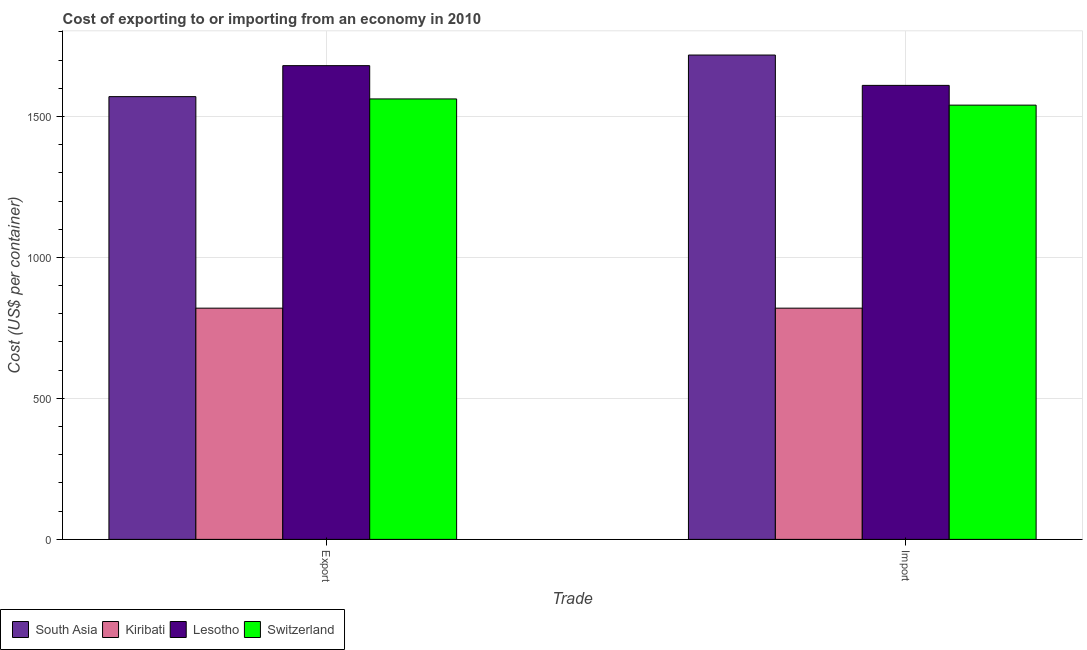How many groups of bars are there?
Keep it short and to the point. 2. Are the number of bars per tick equal to the number of legend labels?
Offer a very short reply. Yes. How many bars are there on the 1st tick from the right?
Ensure brevity in your answer.  4. What is the label of the 1st group of bars from the left?
Your answer should be very brief. Export. What is the import cost in Lesotho?
Your answer should be compact. 1610. Across all countries, what is the maximum import cost?
Your answer should be very brief. 1717.62. Across all countries, what is the minimum import cost?
Offer a very short reply. 820. In which country was the import cost maximum?
Keep it short and to the point. South Asia. In which country was the import cost minimum?
Make the answer very short. Kiribati. What is the total export cost in the graph?
Your answer should be very brief. 5632.12. What is the difference between the export cost in South Asia and that in Kiribati?
Provide a short and direct response. 750.12. What is the difference between the export cost in Lesotho and the import cost in Switzerland?
Provide a short and direct response. 140. What is the average import cost per country?
Ensure brevity in your answer.  1421.91. In how many countries, is the import cost greater than 900 US$?
Provide a succinct answer. 3. What is the ratio of the import cost in Lesotho to that in South Asia?
Offer a very short reply. 0.94. What does the 1st bar from the left in Import represents?
Offer a very short reply. South Asia. What does the 3rd bar from the right in Export represents?
Offer a terse response. Kiribati. What is the difference between two consecutive major ticks on the Y-axis?
Your response must be concise. 500. Are the values on the major ticks of Y-axis written in scientific E-notation?
Ensure brevity in your answer.  No. Where does the legend appear in the graph?
Your answer should be compact. Bottom left. How are the legend labels stacked?
Your answer should be very brief. Horizontal. What is the title of the graph?
Provide a succinct answer. Cost of exporting to or importing from an economy in 2010. What is the label or title of the X-axis?
Give a very brief answer. Trade. What is the label or title of the Y-axis?
Keep it short and to the point. Cost (US$ per container). What is the Cost (US$ per container) of South Asia in Export?
Ensure brevity in your answer.  1570.12. What is the Cost (US$ per container) in Kiribati in Export?
Keep it short and to the point. 820. What is the Cost (US$ per container) of Lesotho in Export?
Give a very brief answer. 1680. What is the Cost (US$ per container) of Switzerland in Export?
Ensure brevity in your answer.  1562. What is the Cost (US$ per container) of South Asia in Import?
Offer a very short reply. 1717.62. What is the Cost (US$ per container) in Kiribati in Import?
Ensure brevity in your answer.  820. What is the Cost (US$ per container) of Lesotho in Import?
Keep it short and to the point. 1610. What is the Cost (US$ per container) of Switzerland in Import?
Keep it short and to the point. 1540. Across all Trade, what is the maximum Cost (US$ per container) of South Asia?
Provide a short and direct response. 1717.62. Across all Trade, what is the maximum Cost (US$ per container) in Kiribati?
Provide a short and direct response. 820. Across all Trade, what is the maximum Cost (US$ per container) in Lesotho?
Ensure brevity in your answer.  1680. Across all Trade, what is the maximum Cost (US$ per container) of Switzerland?
Provide a short and direct response. 1562. Across all Trade, what is the minimum Cost (US$ per container) of South Asia?
Your response must be concise. 1570.12. Across all Trade, what is the minimum Cost (US$ per container) in Kiribati?
Your answer should be very brief. 820. Across all Trade, what is the minimum Cost (US$ per container) in Lesotho?
Make the answer very short. 1610. Across all Trade, what is the minimum Cost (US$ per container) of Switzerland?
Provide a short and direct response. 1540. What is the total Cost (US$ per container) of South Asia in the graph?
Provide a short and direct response. 3287.75. What is the total Cost (US$ per container) of Kiribati in the graph?
Keep it short and to the point. 1640. What is the total Cost (US$ per container) of Lesotho in the graph?
Provide a short and direct response. 3290. What is the total Cost (US$ per container) in Switzerland in the graph?
Your answer should be compact. 3102. What is the difference between the Cost (US$ per container) of South Asia in Export and that in Import?
Your answer should be very brief. -147.5. What is the difference between the Cost (US$ per container) in Kiribati in Export and that in Import?
Offer a very short reply. 0. What is the difference between the Cost (US$ per container) in Lesotho in Export and that in Import?
Make the answer very short. 70. What is the difference between the Cost (US$ per container) in Switzerland in Export and that in Import?
Provide a short and direct response. 22. What is the difference between the Cost (US$ per container) in South Asia in Export and the Cost (US$ per container) in Kiribati in Import?
Offer a terse response. 750.12. What is the difference between the Cost (US$ per container) in South Asia in Export and the Cost (US$ per container) in Lesotho in Import?
Give a very brief answer. -39.88. What is the difference between the Cost (US$ per container) of South Asia in Export and the Cost (US$ per container) of Switzerland in Import?
Make the answer very short. 30.12. What is the difference between the Cost (US$ per container) in Kiribati in Export and the Cost (US$ per container) in Lesotho in Import?
Your answer should be very brief. -790. What is the difference between the Cost (US$ per container) in Kiribati in Export and the Cost (US$ per container) in Switzerland in Import?
Provide a short and direct response. -720. What is the difference between the Cost (US$ per container) of Lesotho in Export and the Cost (US$ per container) of Switzerland in Import?
Give a very brief answer. 140. What is the average Cost (US$ per container) in South Asia per Trade?
Provide a succinct answer. 1643.88. What is the average Cost (US$ per container) in Kiribati per Trade?
Provide a short and direct response. 820. What is the average Cost (US$ per container) in Lesotho per Trade?
Provide a succinct answer. 1645. What is the average Cost (US$ per container) in Switzerland per Trade?
Provide a short and direct response. 1551. What is the difference between the Cost (US$ per container) of South Asia and Cost (US$ per container) of Kiribati in Export?
Offer a terse response. 750.12. What is the difference between the Cost (US$ per container) of South Asia and Cost (US$ per container) of Lesotho in Export?
Your response must be concise. -109.88. What is the difference between the Cost (US$ per container) of South Asia and Cost (US$ per container) of Switzerland in Export?
Offer a very short reply. 8.12. What is the difference between the Cost (US$ per container) of Kiribati and Cost (US$ per container) of Lesotho in Export?
Keep it short and to the point. -860. What is the difference between the Cost (US$ per container) in Kiribati and Cost (US$ per container) in Switzerland in Export?
Offer a terse response. -742. What is the difference between the Cost (US$ per container) of Lesotho and Cost (US$ per container) of Switzerland in Export?
Provide a short and direct response. 118. What is the difference between the Cost (US$ per container) in South Asia and Cost (US$ per container) in Kiribati in Import?
Provide a short and direct response. 897.62. What is the difference between the Cost (US$ per container) of South Asia and Cost (US$ per container) of Lesotho in Import?
Your answer should be compact. 107.62. What is the difference between the Cost (US$ per container) of South Asia and Cost (US$ per container) of Switzerland in Import?
Your answer should be very brief. 177.62. What is the difference between the Cost (US$ per container) in Kiribati and Cost (US$ per container) in Lesotho in Import?
Give a very brief answer. -790. What is the difference between the Cost (US$ per container) of Kiribati and Cost (US$ per container) of Switzerland in Import?
Your answer should be compact. -720. What is the ratio of the Cost (US$ per container) in South Asia in Export to that in Import?
Provide a short and direct response. 0.91. What is the ratio of the Cost (US$ per container) of Kiribati in Export to that in Import?
Ensure brevity in your answer.  1. What is the ratio of the Cost (US$ per container) of Lesotho in Export to that in Import?
Your response must be concise. 1.04. What is the ratio of the Cost (US$ per container) in Switzerland in Export to that in Import?
Offer a very short reply. 1.01. What is the difference between the highest and the second highest Cost (US$ per container) in South Asia?
Your answer should be very brief. 147.5. What is the difference between the highest and the lowest Cost (US$ per container) in South Asia?
Ensure brevity in your answer.  147.5. 